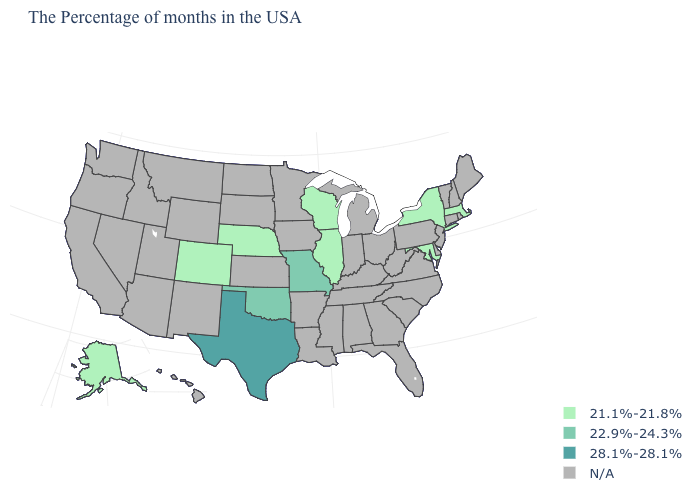Is the legend a continuous bar?
Keep it brief. No. Which states have the lowest value in the MidWest?
Concise answer only. Wisconsin, Illinois, Nebraska. How many symbols are there in the legend?
Keep it brief. 4. What is the value of Maryland?
Keep it brief. 21.1%-21.8%. Name the states that have a value in the range 22.9%-24.3%?
Quick response, please. Missouri, Oklahoma. Does Texas have the highest value in the USA?
Short answer required. Yes. How many symbols are there in the legend?
Keep it brief. 4. Name the states that have a value in the range 28.1%-28.1%?
Quick response, please. Texas. What is the value of Rhode Island?
Be succinct. N/A. What is the lowest value in states that border Utah?
Answer briefly. 21.1%-21.8%. Name the states that have a value in the range N/A?
Short answer required. Maine, Rhode Island, New Hampshire, Vermont, Connecticut, New Jersey, Delaware, Pennsylvania, Virginia, North Carolina, South Carolina, West Virginia, Ohio, Florida, Georgia, Michigan, Kentucky, Indiana, Alabama, Tennessee, Mississippi, Louisiana, Arkansas, Minnesota, Iowa, Kansas, South Dakota, North Dakota, Wyoming, New Mexico, Utah, Montana, Arizona, Idaho, Nevada, California, Washington, Oregon, Hawaii. What is the value of New Jersey?
Short answer required. N/A. 